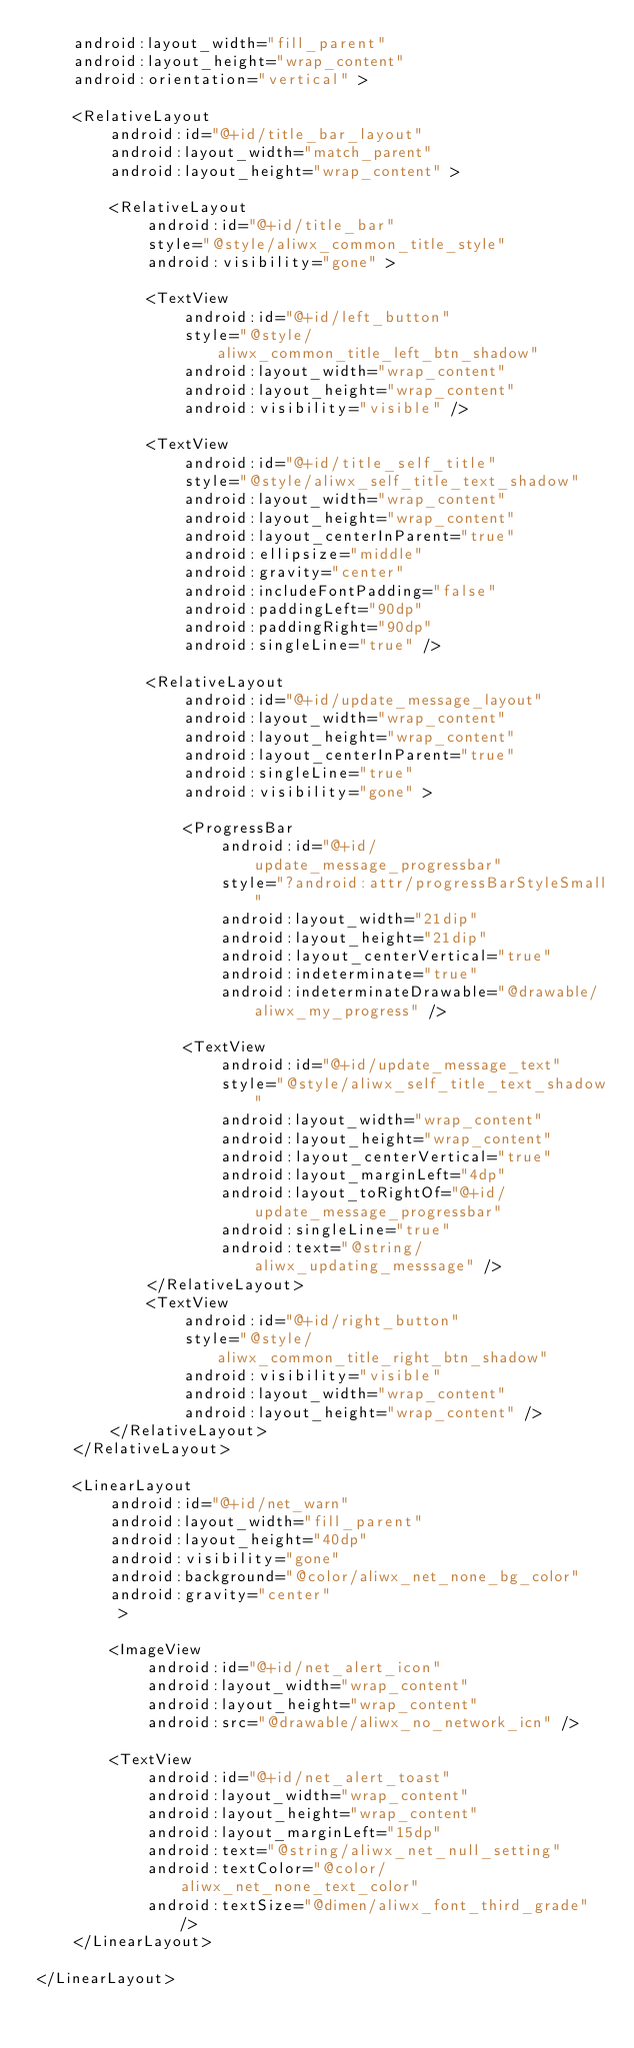<code> <loc_0><loc_0><loc_500><loc_500><_XML_>    android:layout_width="fill_parent"
    android:layout_height="wrap_content"
    android:orientation="vertical" >

    <RelativeLayout
        android:id="@+id/title_bar_layout"
        android:layout_width="match_parent"
        android:layout_height="wrap_content" >

        <RelativeLayout
            android:id="@+id/title_bar"
            style="@style/aliwx_common_title_style"
            android:visibility="gone" >

            <TextView
                android:id="@+id/left_button"
                style="@style/aliwx_common_title_left_btn_shadow"
                android:layout_width="wrap_content"
                android:layout_height="wrap_content"
                android:visibility="visible" />

            <TextView
                android:id="@+id/title_self_title"
                style="@style/aliwx_self_title_text_shadow"
                android:layout_width="wrap_content"
                android:layout_height="wrap_content"
                android:layout_centerInParent="true"
                android:ellipsize="middle"
                android:gravity="center"
                android:includeFontPadding="false"
                android:paddingLeft="90dp"
                android:paddingRight="90dp"
                android:singleLine="true" />

            <RelativeLayout
                android:id="@+id/update_message_layout"
                android:layout_width="wrap_content"
                android:layout_height="wrap_content"
                android:layout_centerInParent="true"
                android:singleLine="true"
                android:visibility="gone" >

                <ProgressBar
                    android:id="@+id/update_message_progressbar"
                    style="?android:attr/progressBarStyleSmall"
                    android:layout_width="21dip"
                    android:layout_height="21dip"
                    android:layout_centerVertical="true"
                    android:indeterminate="true"
                    android:indeterminateDrawable="@drawable/aliwx_my_progress" />

                <TextView
                    android:id="@+id/update_message_text"
                    style="@style/aliwx_self_title_text_shadow"
                    android:layout_width="wrap_content"
                    android:layout_height="wrap_content"
                    android:layout_centerVertical="true"
                    android:layout_marginLeft="4dp"
                    android:layout_toRightOf="@+id/update_message_progressbar"
                    android:singleLine="true"
                    android:text="@string/aliwx_updating_messsage" />
            </RelativeLayout>
            <TextView
                android:id="@+id/right_button"
                style="@style/aliwx_common_title_right_btn_shadow"
                android:visibility="visible"
                android:layout_width="wrap_content"
                android:layout_height="wrap_content" />
        </RelativeLayout>
    </RelativeLayout>

    <LinearLayout
        android:id="@+id/net_warn"
        android:layout_width="fill_parent"
        android:layout_height="40dp"
        android:visibility="gone"
        android:background="@color/aliwx_net_none_bg_color"
        android:gravity="center"
         >

        <ImageView
            android:id="@+id/net_alert_icon"
            android:layout_width="wrap_content"
            android:layout_height="wrap_content"
            android:src="@drawable/aliwx_no_network_icn" />

        <TextView
            android:id="@+id/net_alert_toast"
            android:layout_width="wrap_content"
            android:layout_height="wrap_content"
            android:layout_marginLeft="15dp"
            android:text="@string/aliwx_net_null_setting"
            android:textColor="@color/aliwx_net_none_text_color"
            android:textSize="@dimen/aliwx_font_third_grade" />
    </LinearLayout>

</LinearLayout></code> 